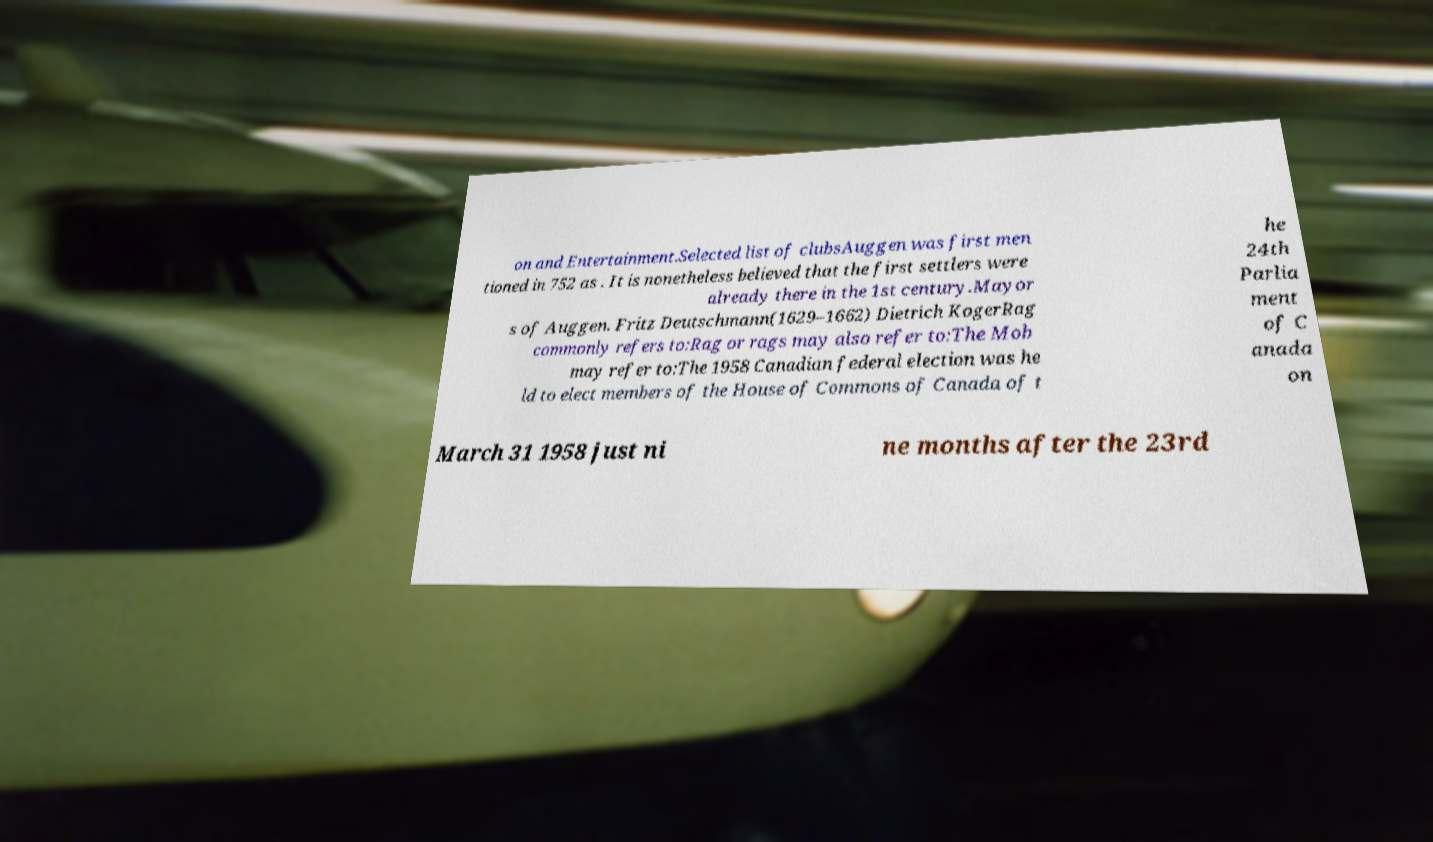I need the written content from this picture converted into text. Can you do that? on and Entertainment.Selected list of clubsAuggen was first men tioned in 752 as . It is nonetheless believed that the first settlers were already there in the 1st century.Mayor s of Auggen. Fritz Deutschmann(1629–1662) Dietrich KogerRag commonly refers to:Rag or rags may also refer to:The Mob may refer to:The 1958 Canadian federal election was he ld to elect members of the House of Commons of Canada of t he 24th Parlia ment of C anada on March 31 1958 just ni ne months after the 23rd 